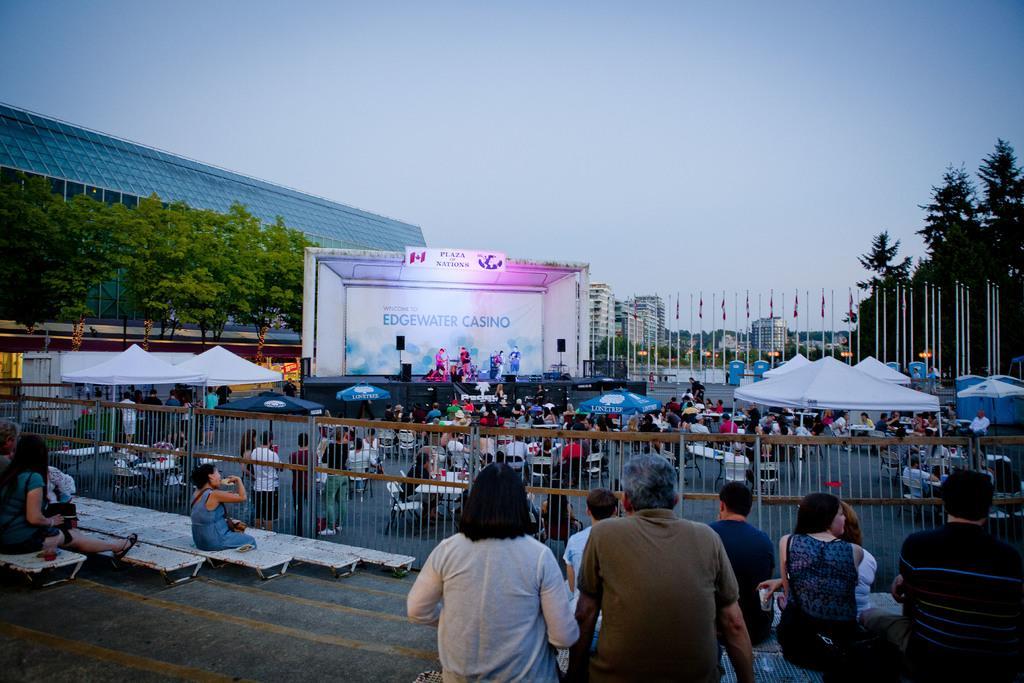How would you summarize this image in a sentence or two? In this image there are buildings, flags with the poles,trees, stage , speakers, umbrellas, stalls, tables, chairs, group of people standing and sitting on the chairs , and in the background there is sky. 